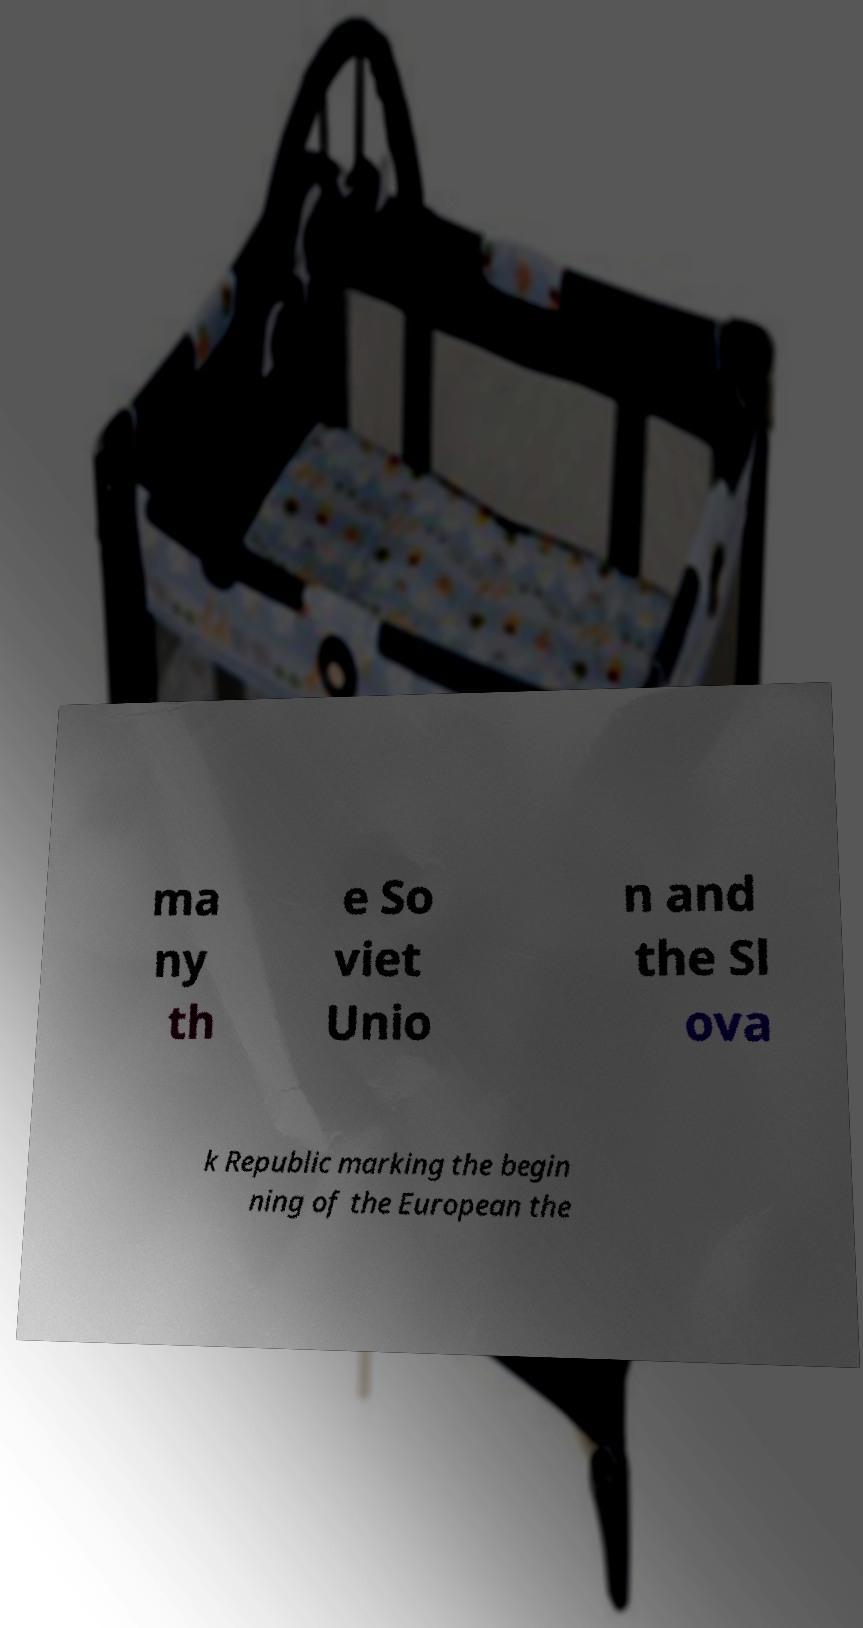Please read and relay the text visible in this image. What does it say? ma ny th e So viet Unio n and the Sl ova k Republic marking the begin ning of the European the 